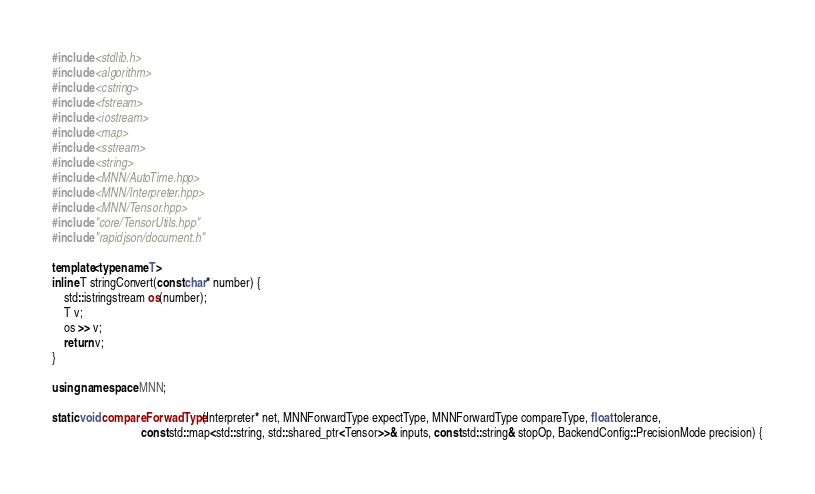Convert code to text. <code><loc_0><loc_0><loc_500><loc_500><_C++_>#include <stdlib.h>
#include <algorithm>
#include <cstring>
#include <fstream>
#include <iostream>
#include <map>
#include <sstream>
#include <string>
#include <MNN/AutoTime.hpp>
#include <MNN/Interpreter.hpp>
#include <MNN/Tensor.hpp>
#include "core/TensorUtils.hpp"
#include "rapidjson/document.h"

template<typename T>
inline T stringConvert(const char* number) {
    std::istringstream os(number);
    T v;
    os >> v;
    return v;
}

using namespace MNN;

static void compareForwadType(Interpreter* net, MNNForwardType expectType, MNNForwardType compareType, float tolerance,
                              const std::map<std::string, std::shared_ptr<Tensor>>& inputs, const std::string& stopOp, BackendConfig::PrecisionMode precision) {</code> 